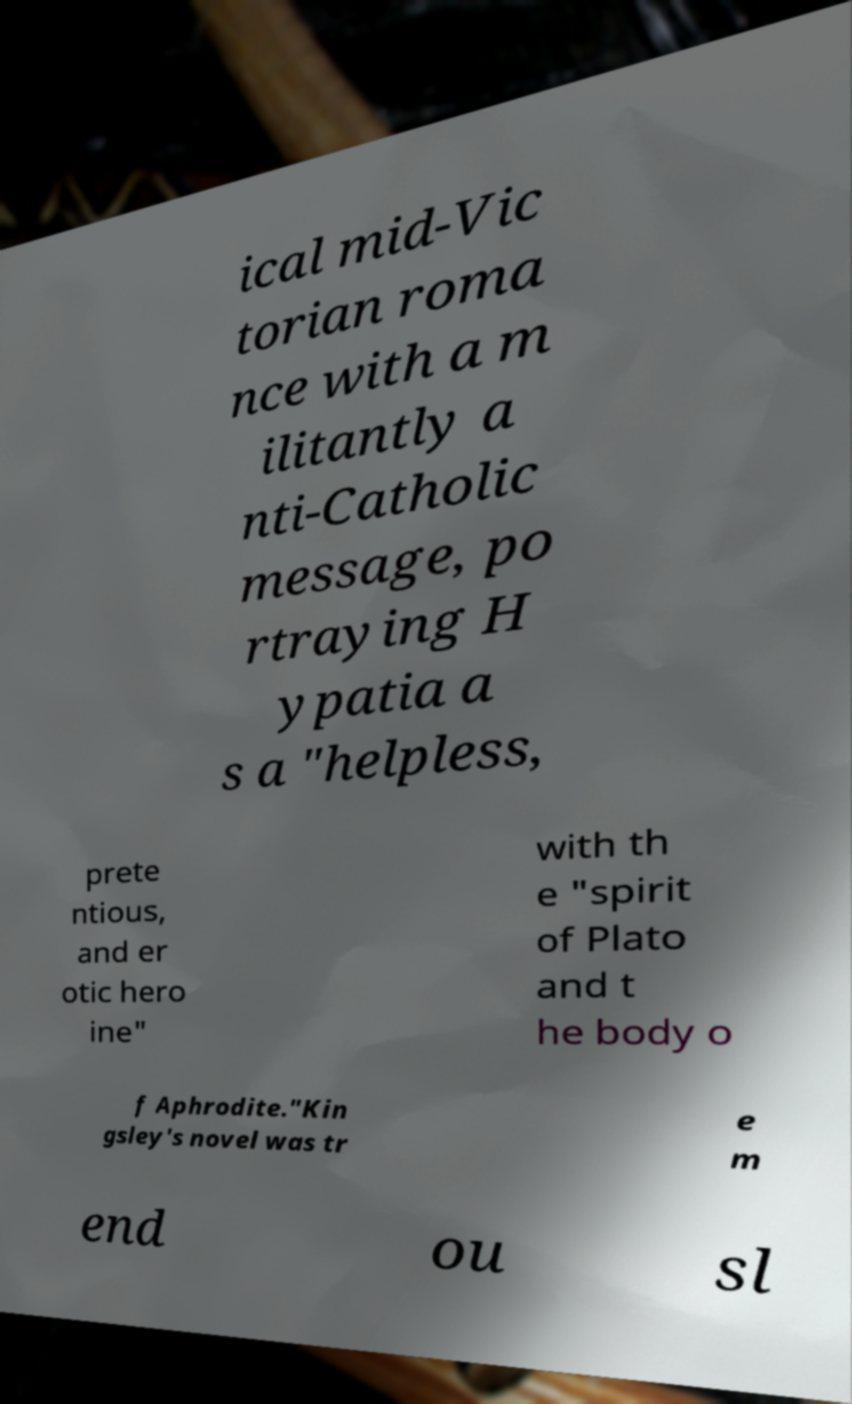Could you assist in decoding the text presented in this image and type it out clearly? ical mid-Vic torian roma nce with a m ilitantly a nti-Catholic message, po rtraying H ypatia a s a "helpless, prete ntious, and er otic hero ine" with th e "spirit of Plato and t he body o f Aphrodite."Kin gsley's novel was tr e m end ou sl 